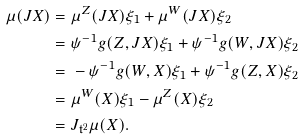Convert formula to latex. <formula><loc_0><loc_0><loc_500><loc_500>\mu ( J X ) = & \ \mu ^ { Z } ( J X ) \xi _ { 1 } + \mu ^ { W } ( J X ) \xi _ { 2 } \\ = & \ \psi ^ { - 1 } g ( Z , J X ) \xi _ { 1 } + \psi ^ { - 1 } g ( W , J X ) \xi _ { 2 } \\ = & \ - \psi ^ { - 1 } g ( W , X ) \xi _ { 1 } + \psi ^ { - 1 } g ( Z , X ) \xi _ { 2 } \\ = & \ \mu ^ { W } ( X ) \xi _ { 1 } - \mu ^ { Z } ( X ) \xi _ { 2 } \\ = & \ J _ { \mathfrak t ^ { 2 } } \mu ( X ) .</formula> 